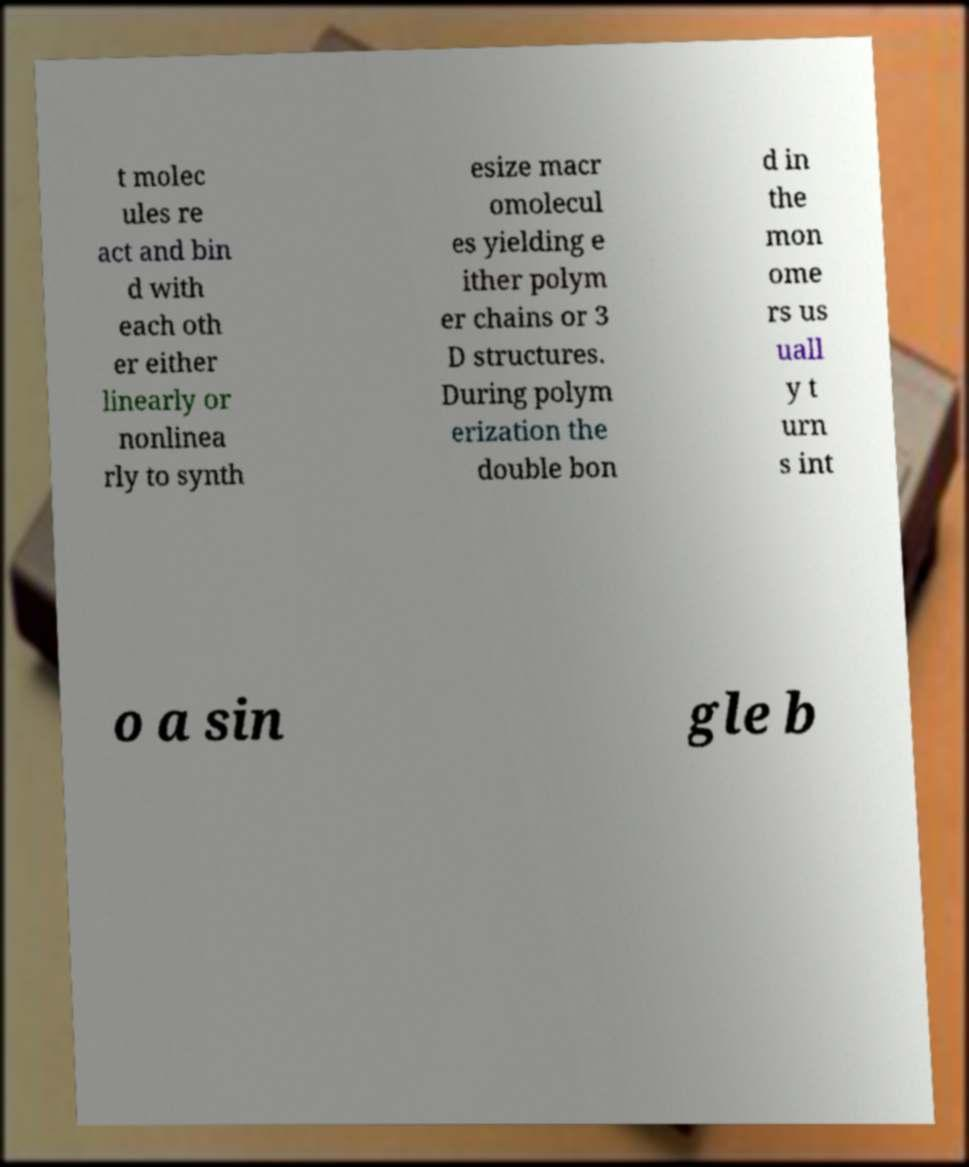Please identify and transcribe the text found in this image. t molec ules re act and bin d with each oth er either linearly or nonlinea rly to synth esize macr omolecul es yielding e ither polym er chains or 3 D structures. During polym erization the double bon d in the mon ome rs us uall y t urn s int o a sin gle b 